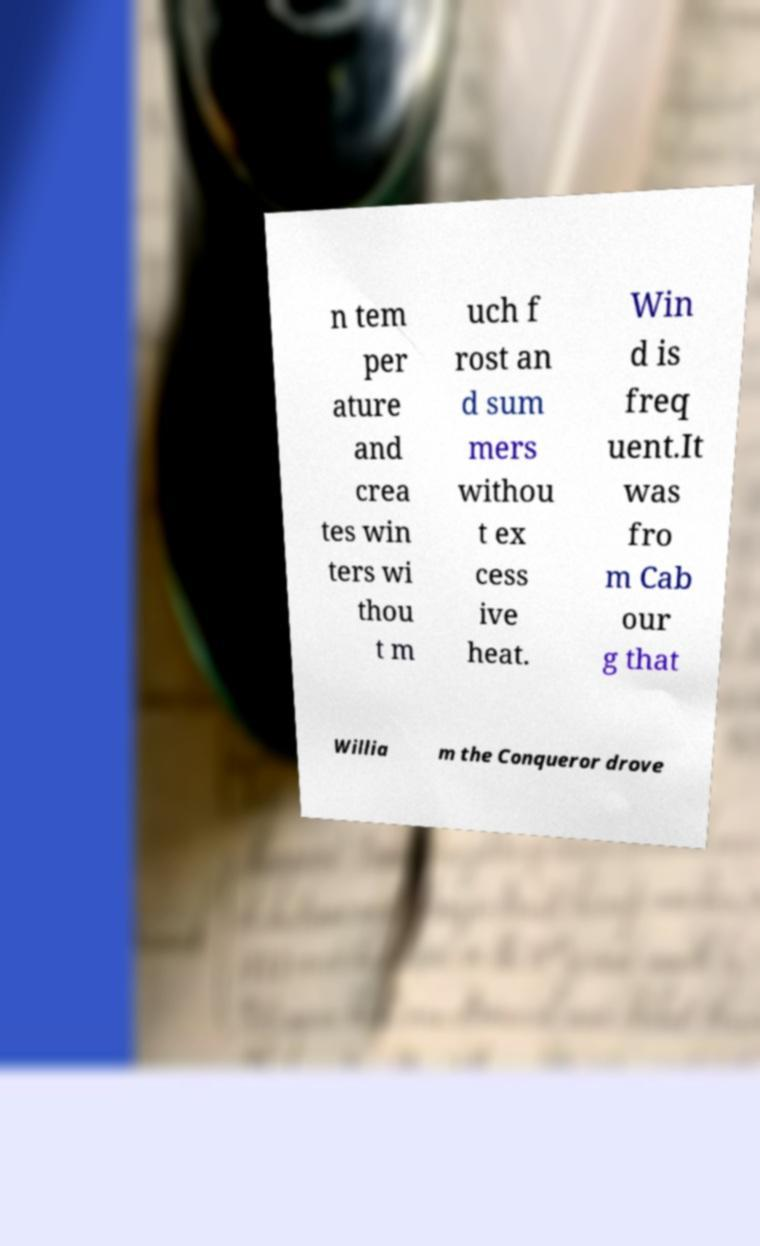Can you accurately transcribe the text from the provided image for me? n tem per ature and crea tes win ters wi thou t m uch f rost an d sum mers withou t ex cess ive heat. Win d is freq uent.It was fro m Cab our g that Willia m the Conqueror drove 